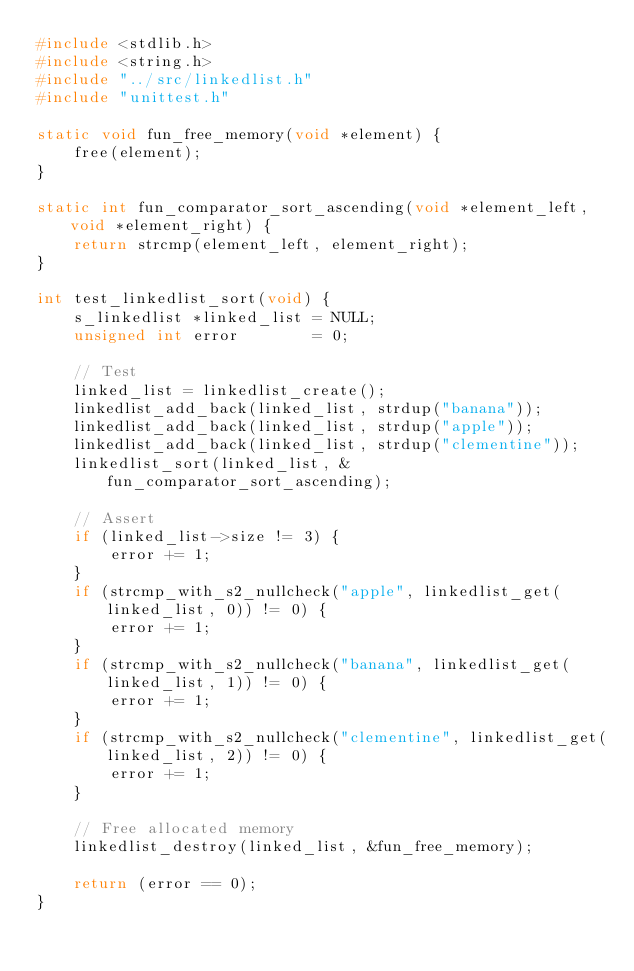<code> <loc_0><loc_0><loc_500><loc_500><_C_>#include <stdlib.h>
#include <string.h>
#include "../src/linkedlist.h"
#include "unittest.h"

static void fun_free_memory(void *element) {
    free(element);
}

static int fun_comparator_sort_ascending(void *element_left, void *element_right) {
    return strcmp(element_left, element_right);
}

int test_linkedlist_sort(void) {
    s_linkedlist *linked_list = NULL;
    unsigned int error        = 0;

    // Test
    linked_list = linkedlist_create();
    linkedlist_add_back(linked_list, strdup("banana"));
    linkedlist_add_back(linked_list, strdup("apple"));
    linkedlist_add_back(linked_list, strdup("clementine"));
    linkedlist_sort(linked_list, &fun_comparator_sort_ascending);

    // Assert
    if (linked_list->size != 3) {
        error += 1;
    }
    if (strcmp_with_s2_nullcheck("apple", linkedlist_get(linked_list, 0)) != 0) {
        error += 1;
    }
    if (strcmp_with_s2_nullcheck("banana", linkedlist_get(linked_list, 1)) != 0) {
        error += 1;
    }
    if (strcmp_with_s2_nullcheck("clementine", linkedlist_get(linked_list, 2)) != 0) {
        error += 1;
    }

    // Free allocated memory
    linkedlist_destroy(linked_list, &fun_free_memory);

    return (error == 0);
}
</code> 